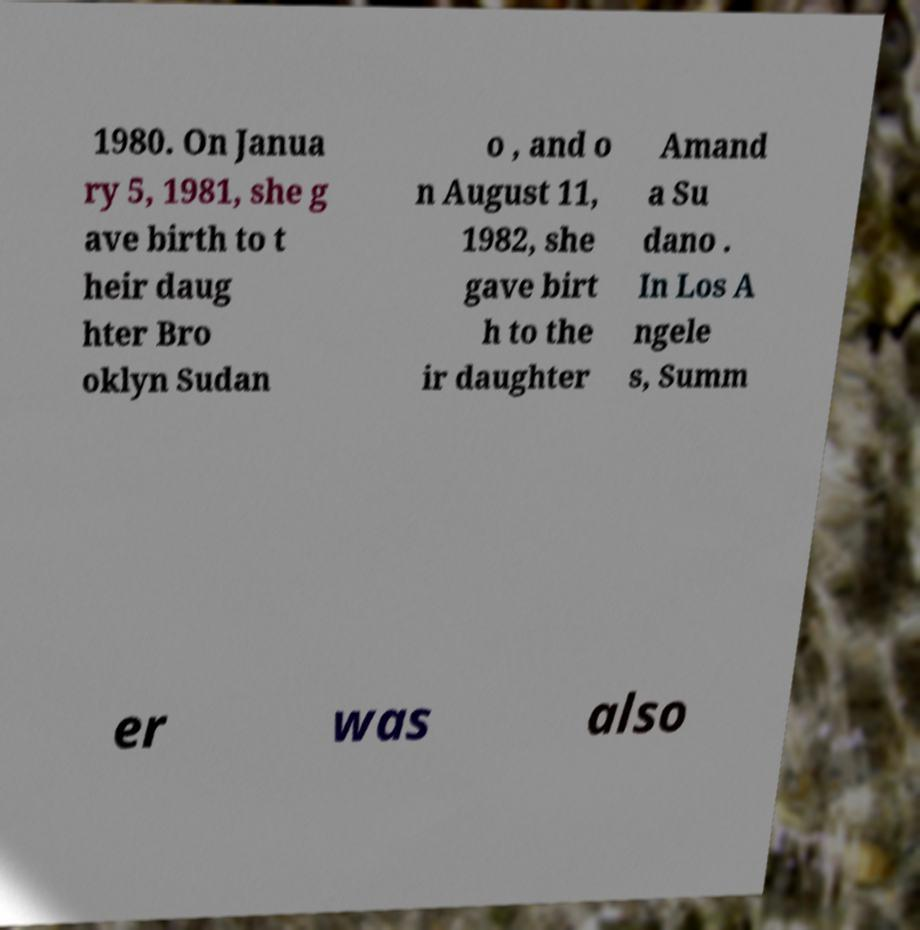I need the written content from this picture converted into text. Can you do that? 1980. On Janua ry 5, 1981, she g ave birth to t heir daug hter Bro oklyn Sudan o , and o n August 11, 1982, she gave birt h to the ir daughter Amand a Su dano . In Los A ngele s, Summ er was also 